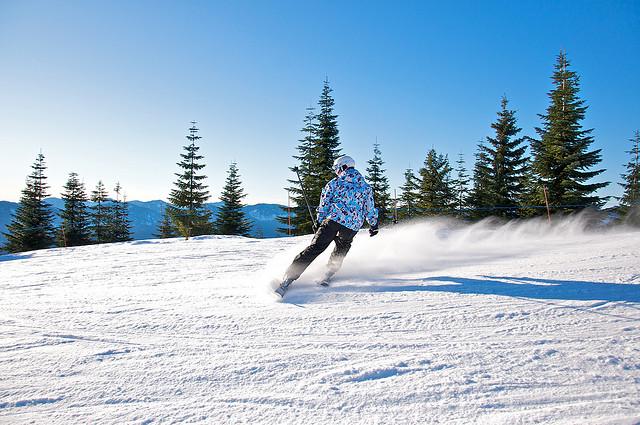Are there any fir trees in the picture?
Quick response, please. Yes. How many trees are there?
Be succinct. 15. What is the person doing?
Give a very brief answer. Skiing. 